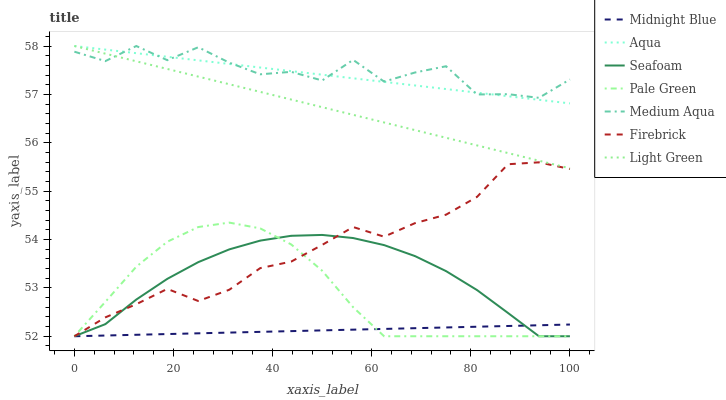Does Midnight Blue have the minimum area under the curve?
Answer yes or no. Yes. Does Medium Aqua have the maximum area under the curve?
Answer yes or no. Yes. Does Firebrick have the minimum area under the curve?
Answer yes or no. No. Does Firebrick have the maximum area under the curve?
Answer yes or no. No. Is Light Green the smoothest?
Answer yes or no. Yes. Is Medium Aqua the roughest?
Answer yes or no. Yes. Is Firebrick the smoothest?
Answer yes or no. No. Is Firebrick the roughest?
Answer yes or no. No. Does Midnight Blue have the lowest value?
Answer yes or no. Yes. Does Aqua have the lowest value?
Answer yes or no. No. Does Light Green have the highest value?
Answer yes or no. Yes. Does Firebrick have the highest value?
Answer yes or no. No. Is Midnight Blue less than Aqua?
Answer yes or no. Yes. Is Light Green greater than Seafoam?
Answer yes or no. Yes. Does Firebrick intersect Pale Green?
Answer yes or no. Yes. Is Firebrick less than Pale Green?
Answer yes or no. No. Is Firebrick greater than Pale Green?
Answer yes or no. No. Does Midnight Blue intersect Aqua?
Answer yes or no. No. 